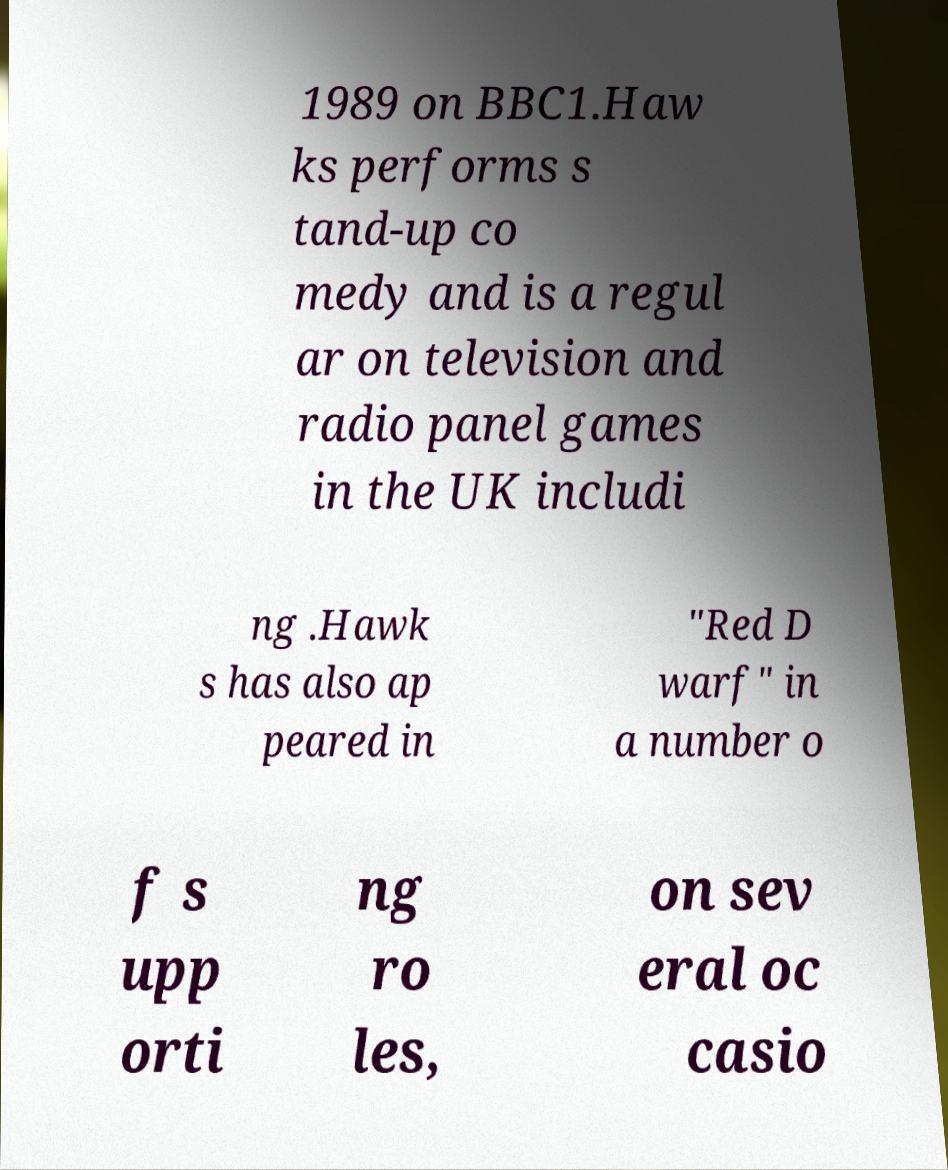Could you extract and type out the text from this image? 1989 on BBC1.Haw ks performs s tand-up co medy and is a regul ar on television and radio panel games in the UK includi ng .Hawk s has also ap peared in "Red D warf" in a number o f s upp orti ng ro les, on sev eral oc casio 